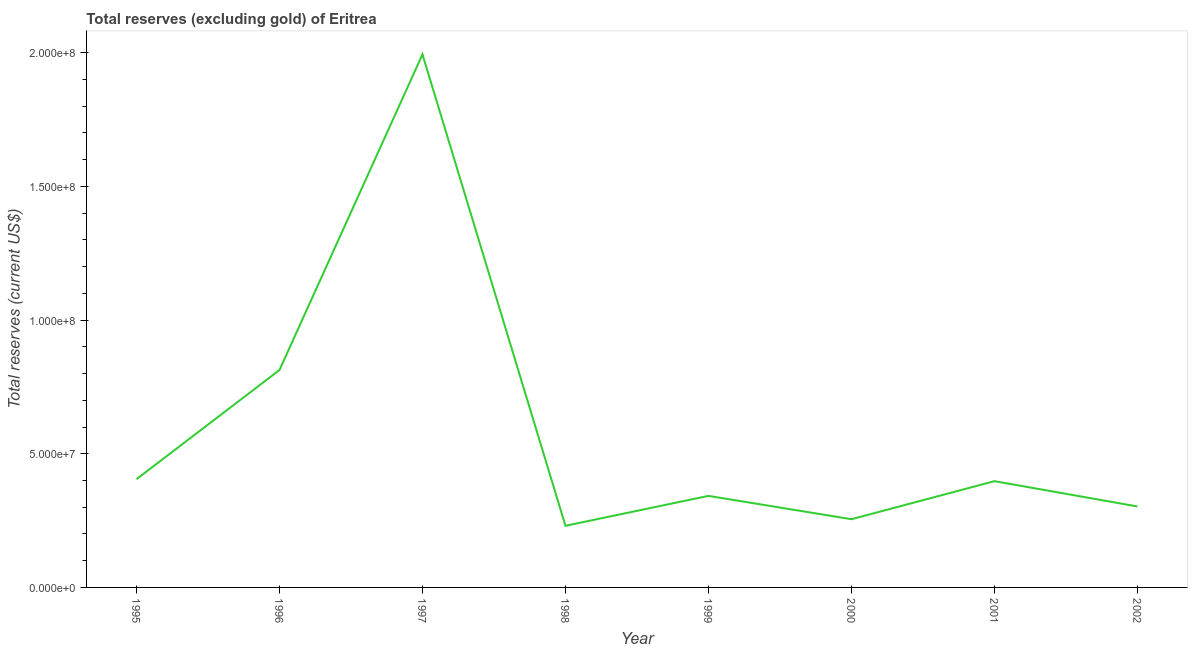What is the total reserves (excluding gold) in 1998?
Your response must be concise. 2.31e+07. Across all years, what is the maximum total reserves (excluding gold)?
Offer a terse response. 1.99e+08. Across all years, what is the minimum total reserves (excluding gold)?
Provide a succinct answer. 2.31e+07. In which year was the total reserves (excluding gold) minimum?
Give a very brief answer. 1998. What is the sum of the total reserves (excluding gold)?
Keep it short and to the point. 4.74e+08. What is the difference between the total reserves (excluding gold) in 1998 and 2002?
Your response must be concise. -7.22e+06. What is the average total reserves (excluding gold) per year?
Ensure brevity in your answer.  5.93e+07. What is the median total reserves (excluding gold)?
Provide a succinct answer. 3.70e+07. In how many years, is the total reserves (excluding gold) greater than 30000000 US$?
Make the answer very short. 6. What is the ratio of the total reserves (excluding gold) in 2000 to that in 2001?
Ensure brevity in your answer.  0.64. Is the total reserves (excluding gold) in 1996 less than that in 2001?
Give a very brief answer. No. Is the difference between the total reserves (excluding gold) in 1996 and 1998 greater than the difference between any two years?
Ensure brevity in your answer.  No. What is the difference between the highest and the second highest total reserves (excluding gold)?
Your answer should be compact. 1.18e+08. Is the sum of the total reserves (excluding gold) in 1996 and 2001 greater than the maximum total reserves (excluding gold) across all years?
Offer a very short reply. No. What is the difference between the highest and the lowest total reserves (excluding gold)?
Make the answer very short. 1.76e+08. In how many years, is the total reserves (excluding gold) greater than the average total reserves (excluding gold) taken over all years?
Make the answer very short. 2. How many lines are there?
Offer a terse response. 1. What is the title of the graph?
Make the answer very short. Total reserves (excluding gold) of Eritrea. What is the label or title of the Y-axis?
Your answer should be compact. Total reserves (current US$). What is the Total reserves (current US$) of 1995?
Offer a very short reply. 4.05e+07. What is the Total reserves (current US$) of 1996?
Your answer should be very brief. 8.13e+07. What is the Total reserves (current US$) in 1997?
Offer a very short reply. 1.99e+08. What is the Total reserves (current US$) in 1998?
Make the answer very short. 2.31e+07. What is the Total reserves (current US$) of 1999?
Offer a very short reply. 3.42e+07. What is the Total reserves (current US$) of 2000?
Offer a very short reply. 2.55e+07. What is the Total reserves (current US$) of 2001?
Your response must be concise. 3.98e+07. What is the Total reserves (current US$) of 2002?
Offer a terse response. 3.03e+07. What is the difference between the Total reserves (current US$) in 1995 and 1996?
Provide a short and direct response. -4.08e+07. What is the difference between the Total reserves (current US$) in 1995 and 1997?
Keep it short and to the point. -1.59e+08. What is the difference between the Total reserves (current US$) in 1995 and 1998?
Provide a succinct answer. 1.74e+07. What is the difference between the Total reserves (current US$) in 1995 and 1999?
Offer a terse response. 6.25e+06. What is the difference between the Total reserves (current US$) in 1995 and 2000?
Give a very brief answer. 1.50e+07. What is the difference between the Total reserves (current US$) in 1995 and 2001?
Provide a short and direct response. 7.35e+05. What is the difference between the Total reserves (current US$) in 1995 and 2002?
Your answer should be very brief. 1.02e+07. What is the difference between the Total reserves (current US$) in 1996 and 1997?
Your answer should be very brief. -1.18e+08. What is the difference between the Total reserves (current US$) in 1996 and 1998?
Your answer should be very brief. 5.83e+07. What is the difference between the Total reserves (current US$) in 1996 and 1999?
Ensure brevity in your answer.  4.71e+07. What is the difference between the Total reserves (current US$) in 1996 and 2000?
Your answer should be compact. 5.58e+07. What is the difference between the Total reserves (current US$) in 1996 and 2001?
Your answer should be compact. 4.16e+07. What is the difference between the Total reserves (current US$) in 1996 and 2002?
Provide a short and direct response. 5.10e+07. What is the difference between the Total reserves (current US$) in 1997 and 1998?
Provide a succinct answer. 1.76e+08. What is the difference between the Total reserves (current US$) in 1997 and 1999?
Provide a short and direct response. 1.65e+08. What is the difference between the Total reserves (current US$) in 1997 and 2000?
Ensure brevity in your answer.  1.74e+08. What is the difference between the Total reserves (current US$) in 1997 and 2001?
Provide a succinct answer. 1.60e+08. What is the difference between the Total reserves (current US$) in 1997 and 2002?
Your answer should be very brief. 1.69e+08. What is the difference between the Total reserves (current US$) in 1998 and 1999?
Offer a terse response. -1.12e+07. What is the difference between the Total reserves (current US$) in 1998 and 2000?
Your answer should be compact. -2.46e+06. What is the difference between the Total reserves (current US$) in 1998 and 2001?
Offer a terse response. -1.67e+07. What is the difference between the Total reserves (current US$) in 1998 and 2002?
Give a very brief answer. -7.22e+06. What is the difference between the Total reserves (current US$) in 1999 and 2000?
Your answer should be very brief. 8.73e+06. What is the difference between the Total reserves (current US$) in 1999 and 2001?
Keep it short and to the point. -5.51e+06. What is the difference between the Total reserves (current US$) in 1999 and 2002?
Offer a very short reply. 3.96e+06. What is the difference between the Total reserves (current US$) in 2000 and 2001?
Make the answer very short. -1.42e+07. What is the difference between the Total reserves (current US$) in 2000 and 2002?
Offer a very short reply. -4.77e+06. What is the difference between the Total reserves (current US$) in 2001 and 2002?
Your answer should be compact. 9.47e+06. What is the ratio of the Total reserves (current US$) in 1995 to that in 1996?
Provide a succinct answer. 0.5. What is the ratio of the Total reserves (current US$) in 1995 to that in 1997?
Make the answer very short. 0.2. What is the ratio of the Total reserves (current US$) in 1995 to that in 1998?
Your answer should be compact. 1.76. What is the ratio of the Total reserves (current US$) in 1995 to that in 1999?
Ensure brevity in your answer.  1.18. What is the ratio of the Total reserves (current US$) in 1995 to that in 2000?
Your answer should be compact. 1.59. What is the ratio of the Total reserves (current US$) in 1995 to that in 2001?
Give a very brief answer. 1.02. What is the ratio of the Total reserves (current US$) in 1995 to that in 2002?
Your answer should be very brief. 1.34. What is the ratio of the Total reserves (current US$) in 1996 to that in 1997?
Make the answer very short. 0.41. What is the ratio of the Total reserves (current US$) in 1996 to that in 1998?
Ensure brevity in your answer.  3.53. What is the ratio of the Total reserves (current US$) in 1996 to that in 1999?
Ensure brevity in your answer.  2.38. What is the ratio of the Total reserves (current US$) in 1996 to that in 2000?
Provide a succinct answer. 3.19. What is the ratio of the Total reserves (current US$) in 1996 to that in 2001?
Your response must be concise. 2.05. What is the ratio of the Total reserves (current US$) in 1996 to that in 2002?
Make the answer very short. 2.69. What is the ratio of the Total reserves (current US$) in 1997 to that in 1998?
Your response must be concise. 8.65. What is the ratio of the Total reserves (current US$) in 1997 to that in 1999?
Your response must be concise. 5.82. What is the ratio of the Total reserves (current US$) in 1997 to that in 2000?
Your answer should be very brief. 7.81. What is the ratio of the Total reserves (current US$) in 1997 to that in 2001?
Offer a terse response. 5.02. What is the ratio of the Total reserves (current US$) in 1997 to that in 2002?
Your response must be concise. 6.58. What is the ratio of the Total reserves (current US$) in 1998 to that in 1999?
Offer a terse response. 0.67. What is the ratio of the Total reserves (current US$) in 1998 to that in 2000?
Give a very brief answer. 0.9. What is the ratio of the Total reserves (current US$) in 1998 to that in 2001?
Provide a short and direct response. 0.58. What is the ratio of the Total reserves (current US$) in 1998 to that in 2002?
Your answer should be very brief. 0.76. What is the ratio of the Total reserves (current US$) in 1999 to that in 2000?
Keep it short and to the point. 1.34. What is the ratio of the Total reserves (current US$) in 1999 to that in 2001?
Offer a terse response. 0.86. What is the ratio of the Total reserves (current US$) in 1999 to that in 2002?
Ensure brevity in your answer.  1.13. What is the ratio of the Total reserves (current US$) in 2000 to that in 2001?
Ensure brevity in your answer.  0.64. What is the ratio of the Total reserves (current US$) in 2000 to that in 2002?
Your response must be concise. 0.84. What is the ratio of the Total reserves (current US$) in 2001 to that in 2002?
Your answer should be compact. 1.31. 